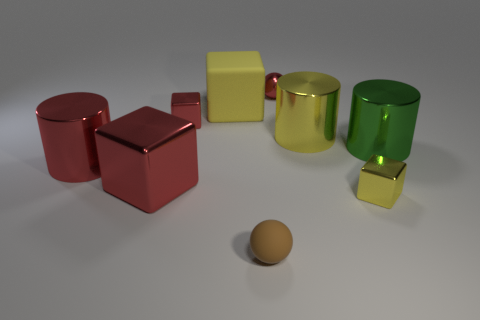What number of big yellow blocks are there?
Give a very brief answer. 1. Is the large cube that is behind the yellow metal cylinder made of the same material as the tiny brown ball?
Provide a short and direct response. Yes. Are there any blue metallic cubes that have the same size as the brown matte thing?
Your answer should be very brief. No. There is a brown matte thing; does it have the same shape as the red object that is right of the brown thing?
Your response must be concise. Yes. There is a large metal cylinder that is to the left of the brown thing in front of the small metal sphere; are there any tiny objects that are behind it?
Give a very brief answer. Yes. What size is the green cylinder?
Provide a succinct answer. Large. What number of other objects are the same color as the metal sphere?
Offer a very short reply. 3. Do the thing in front of the yellow metal cube and the tiny yellow object have the same shape?
Make the answer very short. No. What is the color of the large metallic object that is the same shape as the small yellow metal thing?
Your response must be concise. Red. There is a rubber object that is the same shape as the tiny yellow shiny thing; what size is it?
Offer a terse response. Large. 